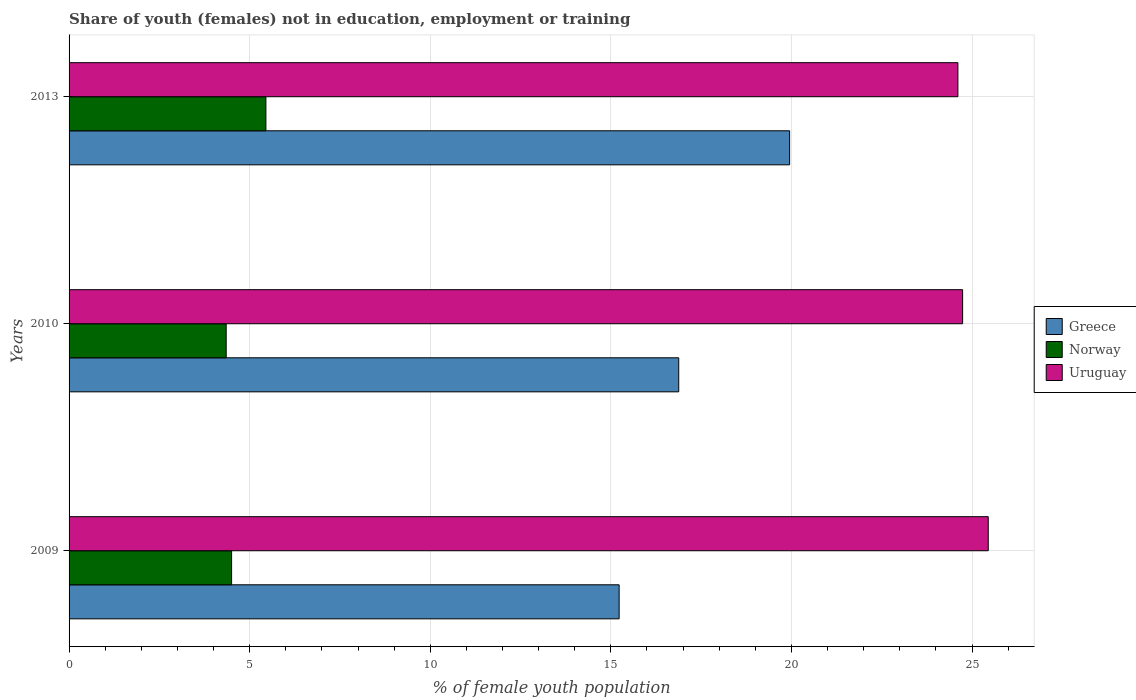How many different coloured bars are there?
Provide a succinct answer. 3. What is the label of the 2nd group of bars from the top?
Your answer should be very brief. 2010. In how many cases, is the number of bars for a given year not equal to the number of legend labels?
Offer a terse response. 0. What is the percentage of unemployed female population in in Greece in 2010?
Your response must be concise. 16.88. Across all years, what is the maximum percentage of unemployed female population in in Uruguay?
Your response must be concise. 25.45. Across all years, what is the minimum percentage of unemployed female population in in Norway?
Your response must be concise. 4.35. In which year was the percentage of unemployed female population in in Greece maximum?
Provide a short and direct response. 2013. In which year was the percentage of unemployed female population in in Greece minimum?
Provide a succinct answer. 2009. What is the total percentage of unemployed female population in in Greece in the graph?
Your response must be concise. 52.06. What is the difference between the percentage of unemployed female population in in Norway in 2010 and that in 2013?
Offer a terse response. -1.1. What is the difference between the percentage of unemployed female population in in Norway in 2010 and the percentage of unemployed female population in in Uruguay in 2009?
Your answer should be very brief. -21.1. What is the average percentage of unemployed female population in in Uruguay per year?
Your answer should be compact. 24.93. In the year 2010, what is the difference between the percentage of unemployed female population in in Greece and percentage of unemployed female population in in Uruguay?
Make the answer very short. -7.86. What is the ratio of the percentage of unemployed female population in in Greece in 2009 to that in 2010?
Give a very brief answer. 0.9. What is the difference between the highest and the second highest percentage of unemployed female population in in Norway?
Make the answer very short. 0.95. What is the difference between the highest and the lowest percentage of unemployed female population in in Norway?
Offer a very short reply. 1.1. What does the 1st bar from the top in 2009 represents?
Offer a terse response. Uruguay. Is it the case that in every year, the sum of the percentage of unemployed female population in in Uruguay and percentage of unemployed female population in in Greece is greater than the percentage of unemployed female population in in Norway?
Ensure brevity in your answer.  Yes. What is the difference between two consecutive major ticks on the X-axis?
Keep it short and to the point. 5. Does the graph contain any zero values?
Your answer should be very brief. No. Where does the legend appear in the graph?
Your response must be concise. Center right. How many legend labels are there?
Ensure brevity in your answer.  3. How are the legend labels stacked?
Provide a short and direct response. Vertical. What is the title of the graph?
Ensure brevity in your answer.  Share of youth (females) not in education, employment or training. What is the label or title of the X-axis?
Your answer should be very brief. % of female youth population. What is the label or title of the Y-axis?
Provide a short and direct response. Years. What is the % of female youth population of Greece in 2009?
Your answer should be compact. 15.23. What is the % of female youth population of Uruguay in 2009?
Your response must be concise. 25.45. What is the % of female youth population in Greece in 2010?
Provide a succinct answer. 16.88. What is the % of female youth population of Norway in 2010?
Offer a very short reply. 4.35. What is the % of female youth population of Uruguay in 2010?
Provide a succinct answer. 24.74. What is the % of female youth population of Greece in 2013?
Keep it short and to the point. 19.95. What is the % of female youth population in Norway in 2013?
Your answer should be very brief. 5.45. What is the % of female youth population of Uruguay in 2013?
Your response must be concise. 24.61. Across all years, what is the maximum % of female youth population in Greece?
Provide a short and direct response. 19.95. Across all years, what is the maximum % of female youth population of Norway?
Your answer should be very brief. 5.45. Across all years, what is the maximum % of female youth population in Uruguay?
Provide a succinct answer. 25.45. Across all years, what is the minimum % of female youth population of Greece?
Make the answer very short. 15.23. Across all years, what is the minimum % of female youth population in Norway?
Your response must be concise. 4.35. Across all years, what is the minimum % of female youth population of Uruguay?
Offer a terse response. 24.61. What is the total % of female youth population in Greece in the graph?
Ensure brevity in your answer.  52.06. What is the total % of female youth population in Uruguay in the graph?
Your answer should be very brief. 74.8. What is the difference between the % of female youth population in Greece in 2009 and that in 2010?
Offer a terse response. -1.65. What is the difference between the % of female youth population of Uruguay in 2009 and that in 2010?
Provide a succinct answer. 0.71. What is the difference between the % of female youth population of Greece in 2009 and that in 2013?
Ensure brevity in your answer.  -4.72. What is the difference between the % of female youth population in Norway in 2009 and that in 2013?
Give a very brief answer. -0.95. What is the difference between the % of female youth population in Uruguay in 2009 and that in 2013?
Your response must be concise. 0.84. What is the difference between the % of female youth population in Greece in 2010 and that in 2013?
Your response must be concise. -3.07. What is the difference between the % of female youth population in Norway in 2010 and that in 2013?
Your answer should be compact. -1.1. What is the difference between the % of female youth population in Uruguay in 2010 and that in 2013?
Give a very brief answer. 0.13. What is the difference between the % of female youth population of Greece in 2009 and the % of female youth population of Norway in 2010?
Offer a terse response. 10.88. What is the difference between the % of female youth population in Greece in 2009 and the % of female youth population in Uruguay in 2010?
Provide a succinct answer. -9.51. What is the difference between the % of female youth population in Norway in 2009 and the % of female youth population in Uruguay in 2010?
Your answer should be compact. -20.24. What is the difference between the % of female youth population in Greece in 2009 and the % of female youth population in Norway in 2013?
Make the answer very short. 9.78. What is the difference between the % of female youth population of Greece in 2009 and the % of female youth population of Uruguay in 2013?
Your answer should be very brief. -9.38. What is the difference between the % of female youth population of Norway in 2009 and the % of female youth population of Uruguay in 2013?
Offer a very short reply. -20.11. What is the difference between the % of female youth population of Greece in 2010 and the % of female youth population of Norway in 2013?
Your answer should be very brief. 11.43. What is the difference between the % of female youth population in Greece in 2010 and the % of female youth population in Uruguay in 2013?
Provide a short and direct response. -7.73. What is the difference between the % of female youth population of Norway in 2010 and the % of female youth population of Uruguay in 2013?
Offer a terse response. -20.26. What is the average % of female youth population in Greece per year?
Provide a succinct answer. 17.35. What is the average % of female youth population in Norway per year?
Make the answer very short. 4.77. What is the average % of female youth population in Uruguay per year?
Give a very brief answer. 24.93. In the year 2009, what is the difference between the % of female youth population in Greece and % of female youth population in Norway?
Make the answer very short. 10.73. In the year 2009, what is the difference between the % of female youth population in Greece and % of female youth population in Uruguay?
Your response must be concise. -10.22. In the year 2009, what is the difference between the % of female youth population of Norway and % of female youth population of Uruguay?
Your response must be concise. -20.95. In the year 2010, what is the difference between the % of female youth population of Greece and % of female youth population of Norway?
Offer a very short reply. 12.53. In the year 2010, what is the difference between the % of female youth population of Greece and % of female youth population of Uruguay?
Provide a short and direct response. -7.86. In the year 2010, what is the difference between the % of female youth population of Norway and % of female youth population of Uruguay?
Provide a succinct answer. -20.39. In the year 2013, what is the difference between the % of female youth population of Greece and % of female youth population of Norway?
Give a very brief answer. 14.5. In the year 2013, what is the difference between the % of female youth population in Greece and % of female youth population in Uruguay?
Ensure brevity in your answer.  -4.66. In the year 2013, what is the difference between the % of female youth population of Norway and % of female youth population of Uruguay?
Your response must be concise. -19.16. What is the ratio of the % of female youth population in Greece in 2009 to that in 2010?
Your answer should be compact. 0.9. What is the ratio of the % of female youth population in Norway in 2009 to that in 2010?
Provide a succinct answer. 1.03. What is the ratio of the % of female youth population in Uruguay in 2009 to that in 2010?
Your answer should be very brief. 1.03. What is the ratio of the % of female youth population in Greece in 2009 to that in 2013?
Offer a very short reply. 0.76. What is the ratio of the % of female youth population of Norway in 2009 to that in 2013?
Your response must be concise. 0.83. What is the ratio of the % of female youth population of Uruguay in 2009 to that in 2013?
Keep it short and to the point. 1.03. What is the ratio of the % of female youth population of Greece in 2010 to that in 2013?
Your response must be concise. 0.85. What is the ratio of the % of female youth population in Norway in 2010 to that in 2013?
Give a very brief answer. 0.8. What is the ratio of the % of female youth population of Uruguay in 2010 to that in 2013?
Your answer should be compact. 1.01. What is the difference between the highest and the second highest % of female youth population of Greece?
Offer a very short reply. 3.07. What is the difference between the highest and the second highest % of female youth population in Uruguay?
Your response must be concise. 0.71. What is the difference between the highest and the lowest % of female youth population in Greece?
Make the answer very short. 4.72. What is the difference between the highest and the lowest % of female youth population in Uruguay?
Offer a terse response. 0.84. 